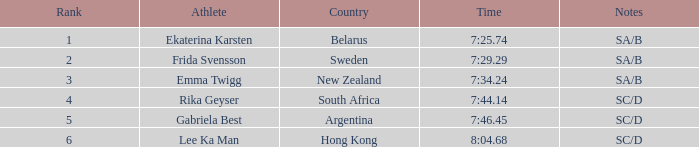What country is the athlete ekaterina karsten from with a rank less than 4? Belarus. 